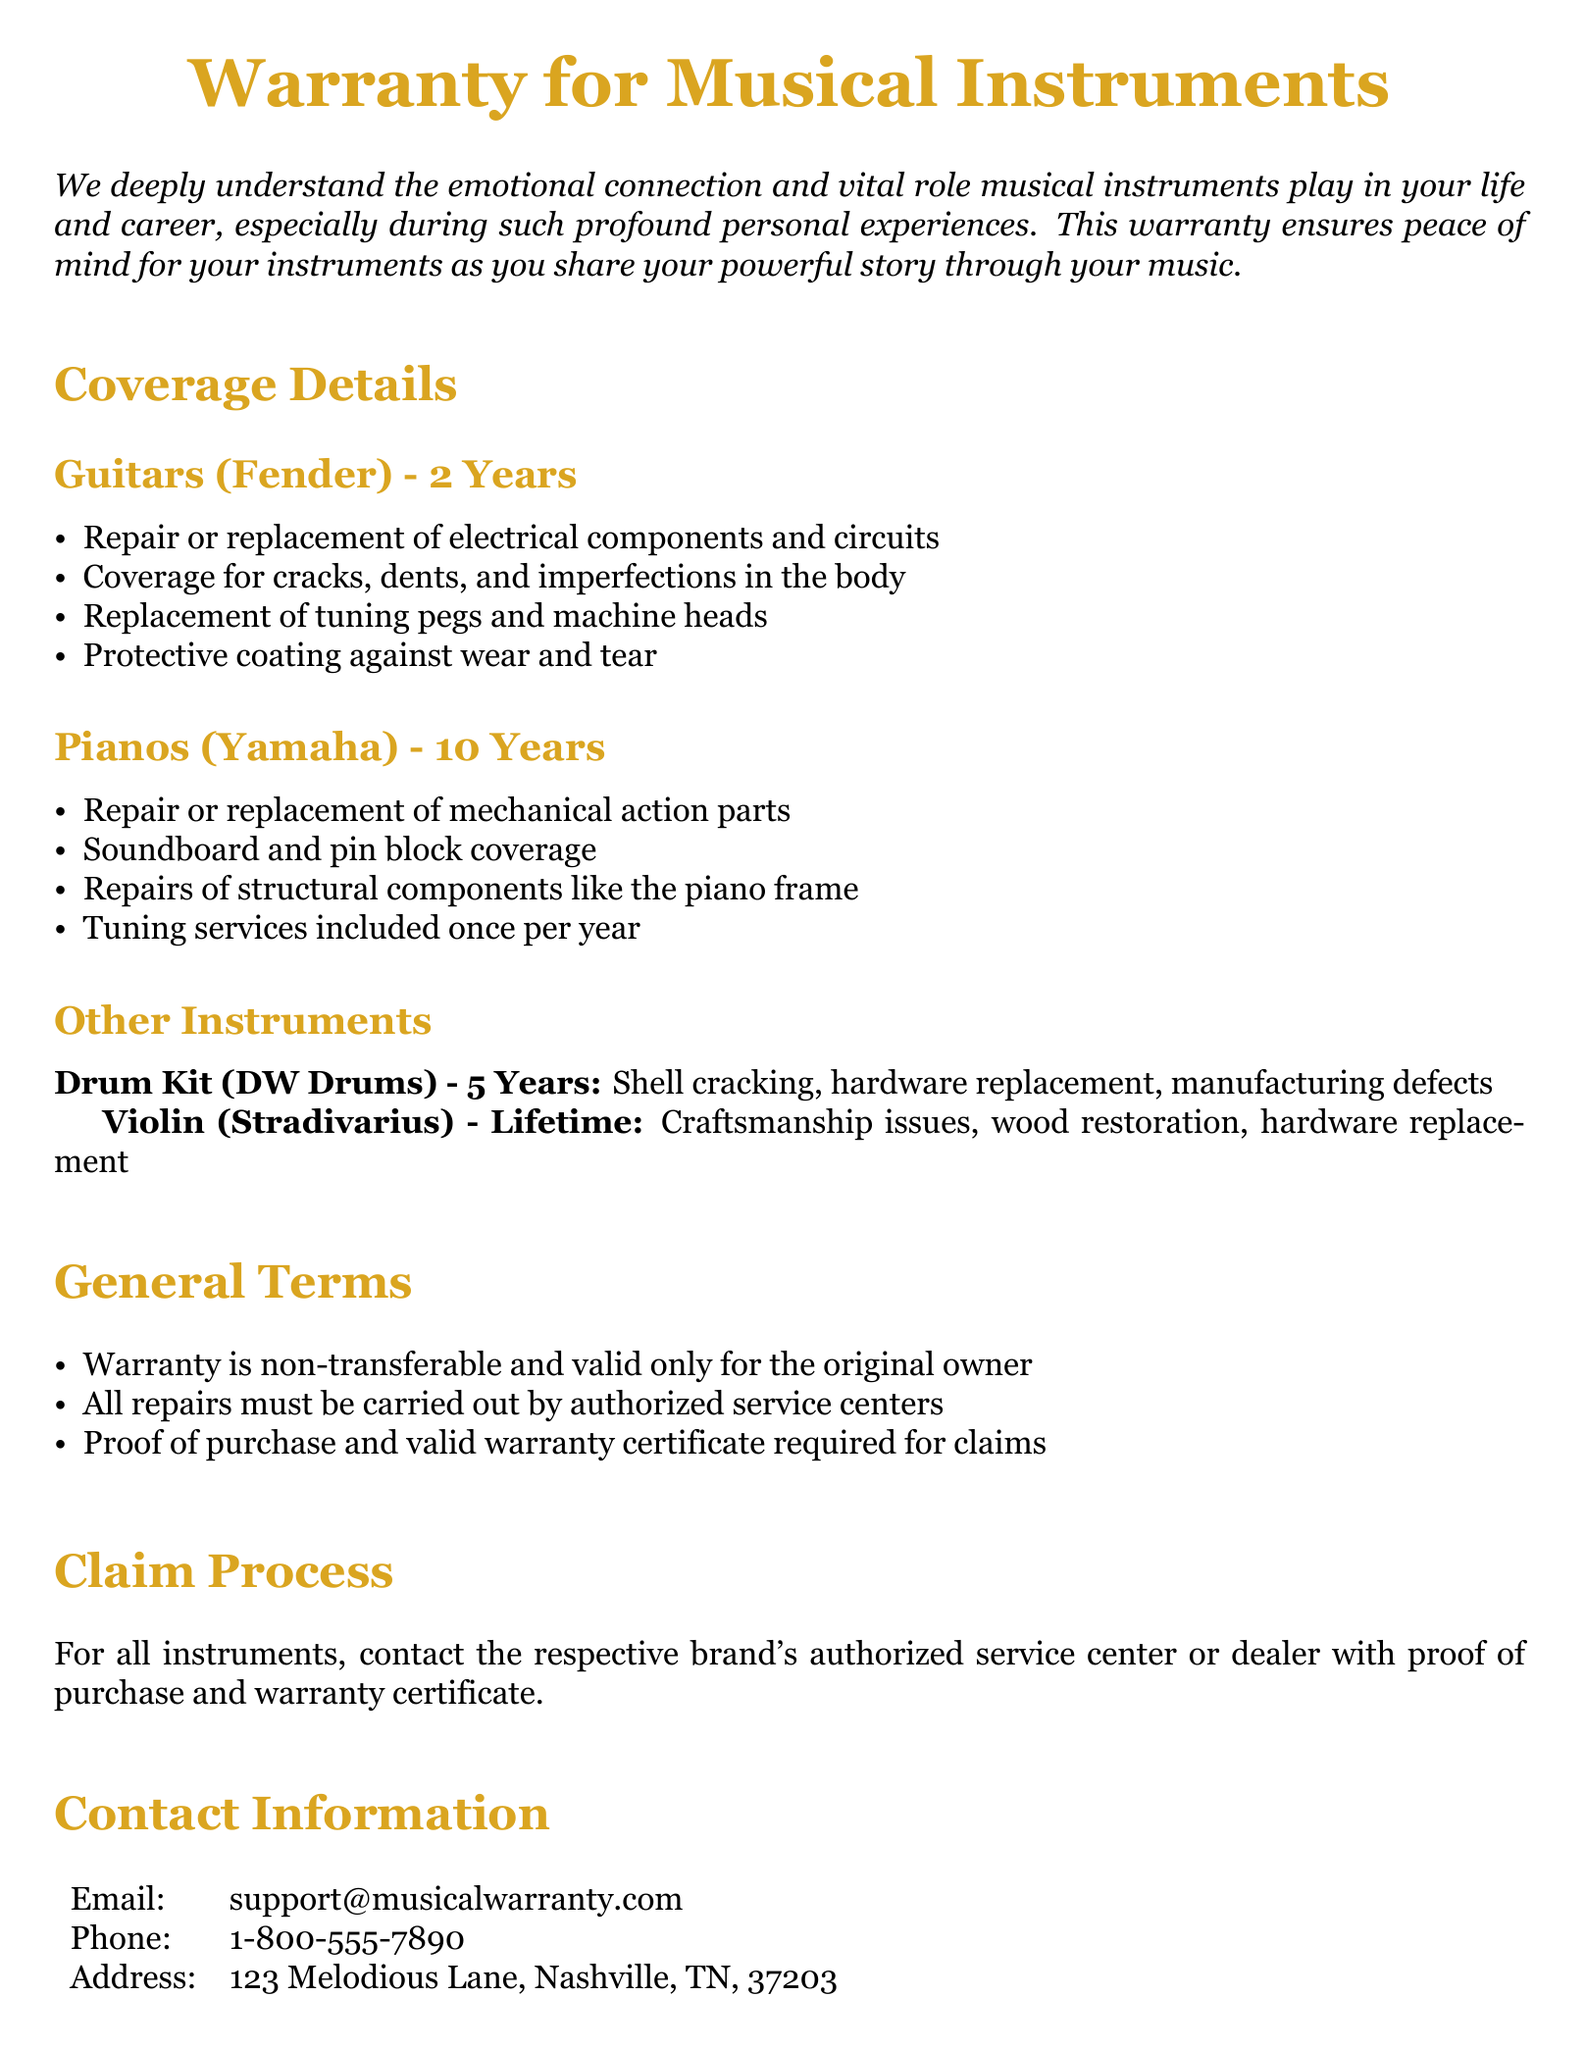What is the warranty duration for guitars? The warranty duration for guitars (Fender) is specifically stated in the document.
Answer: 2 Years What is covered under the Yamaha piano warranty? The document outlines specific coverage details for pianos, including "repair or replacement of mechanical action parts."
Answer: Mechanical action parts What is the contact phone number for support? The document lists a specific phone number for customer support inquiries.
Answer: 1-800-555-7890 Is the warranty transferable? The document specifies a condition regarding the warranty's validity and transferability.
Answer: Non-transferable How long is the warranty for the Stradivarius violin? The warranty period for the Stradivarius violin is stated clearly in the coverage section.
Answer: Lifetime What type of instruments does this warranty cover? The document lists various instruments that the warranty applies to, allowing for easy identification.
Answer: Guitars, pianos, drum kits, violins What is included in the general terms of the warranty? The document provides conditions applicable to the warranty, reflecting essential aspects such as validity and service requirements.
Answer: Warranty is non-transferable How often is tuning included for pianos? The warranty details mention a specific frequency for tuning services under piano coverage.
Answer: Once per year 